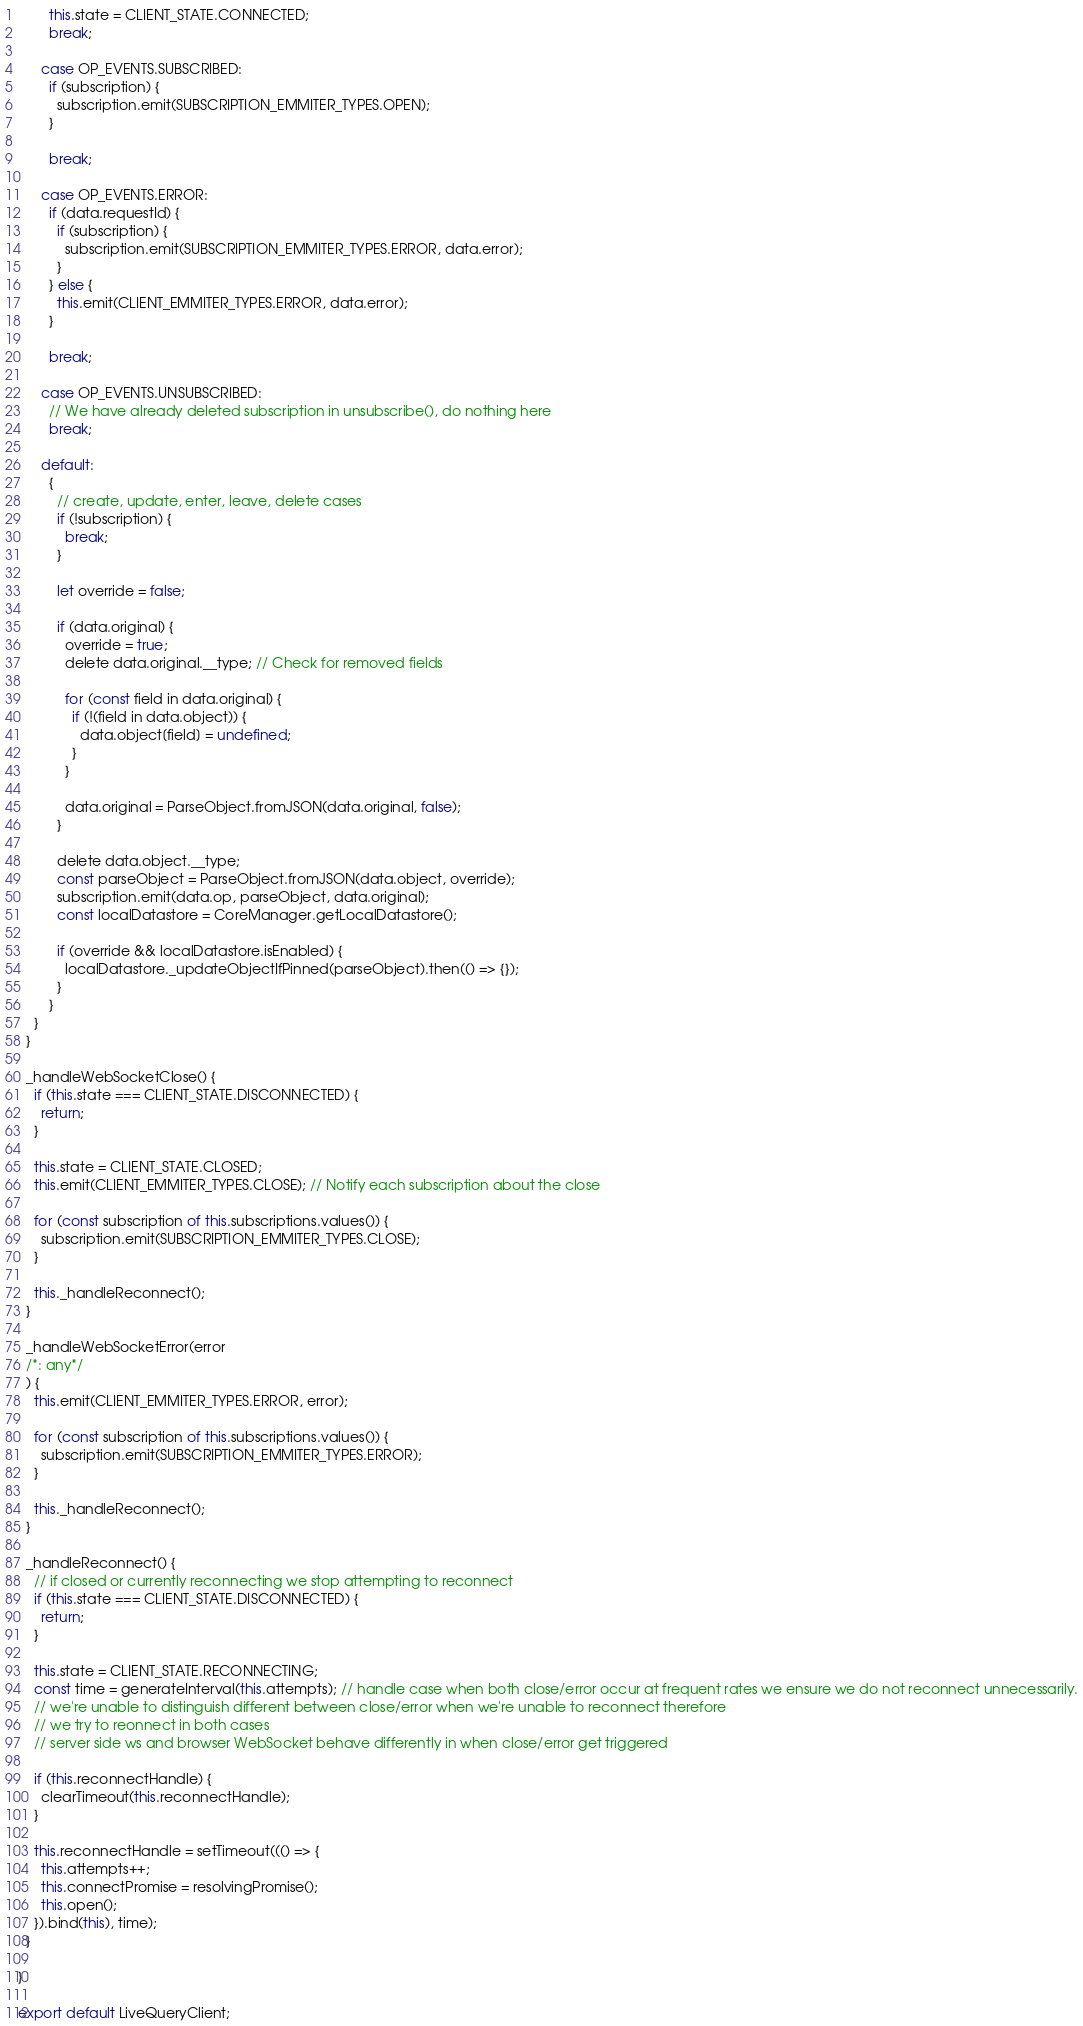Convert code to text. <code><loc_0><loc_0><loc_500><loc_500><_JavaScript_>        this.state = CLIENT_STATE.CONNECTED;
        break;

      case OP_EVENTS.SUBSCRIBED:
        if (subscription) {
          subscription.emit(SUBSCRIPTION_EMMITER_TYPES.OPEN);
        }

        break;

      case OP_EVENTS.ERROR:
        if (data.requestId) {
          if (subscription) {
            subscription.emit(SUBSCRIPTION_EMMITER_TYPES.ERROR, data.error);
          }
        } else {
          this.emit(CLIENT_EMMITER_TYPES.ERROR, data.error);
        }

        break;

      case OP_EVENTS.UNSUBSCRIBED:
        // We have already deleted subscription in unsubscribe(), do nothing here
        break;

      default:
        {
          // create, update, enter, leave, delete cases
          if (!subscription) {
            break;
          }

          let override = false;

          if (data.original) {
            override = true;
            delete data.original.__type; // Check for removed fields

            for (const field in data.original) {
              if (!(field in data.object)) {
                data.object[field] = undefined;
              }
            }

            data.original = ParseObject.fromJSON(data.original, false);
          }

          delete data.object.__type;
          const parseObject = ParseObject.fromJSON(data.object, override);
          subscription.emit(data.op, parseObject, data.original);
          const localDatastore = CoreManager.getLocalDatastore();

          if (override && localDatastore.isEnabled) {
            localDatastore._updateObjectIfPinned(parseObject).then(() => {});
          }
        }
    }
  }

  _handleWebSocketClose() {
    if (this.state === CLIENT_STATE.DISCONNECTED) {
      return;
    }

    this.state = CLIENT_STATE.CLOSED;
    this.emit(CLIENT_EMMITER_TYPES.CLOSE); // Notify each subscription about the close

    for (const subscription of this.subscriptions.values()) {
      subscription.emit(SUBSCRIPTION_EMMITER_TYPES.CLOSE);
    }

    this._handleReconnect();
  }

  _handleWebSocketError(error
  /*: any*/
  ) {
    this.emit(CLIENT_EMMITER_TYPES.ERROR, error);

    for (const subscription of this.subscriptions.values()) {
      subscription.emit(SUBSCRIPTION_EMMITER_TYPES.ERROR);
    }

    this._handleReconnect();
  }

  _handleReconnect() {
    // if closed or currently reconnecting we stop attempting to reconnect
    if (this.state === CLIENT_STATE.DISCONNECTED) {
      return;
    }

    this.state = CLIENT_STATE.RECONNECTING;
    const time = generateInterval(this.attempts); // handle case when both close/error occur at frequent rates we ensure we do not reconnect unnecessarily.
    // we're unable to distinguish different between close/error when we're unable to reconnect therefore
    // we try to reonnect in both cases
    // server side ws and browser WebSocket behave differently in when close/error get triggered

    if (this.reconnectHandle) {
      clearTimeout(this.reconnectHandle);
    }

    this.reconnectHandle = setTimeout((() => {
      this.attempts++;
      this.connectPromise = resolvingPromise();
      this.open();
    }).bind(this), time);
  }

}

export default LiveQueryClient;</code> 